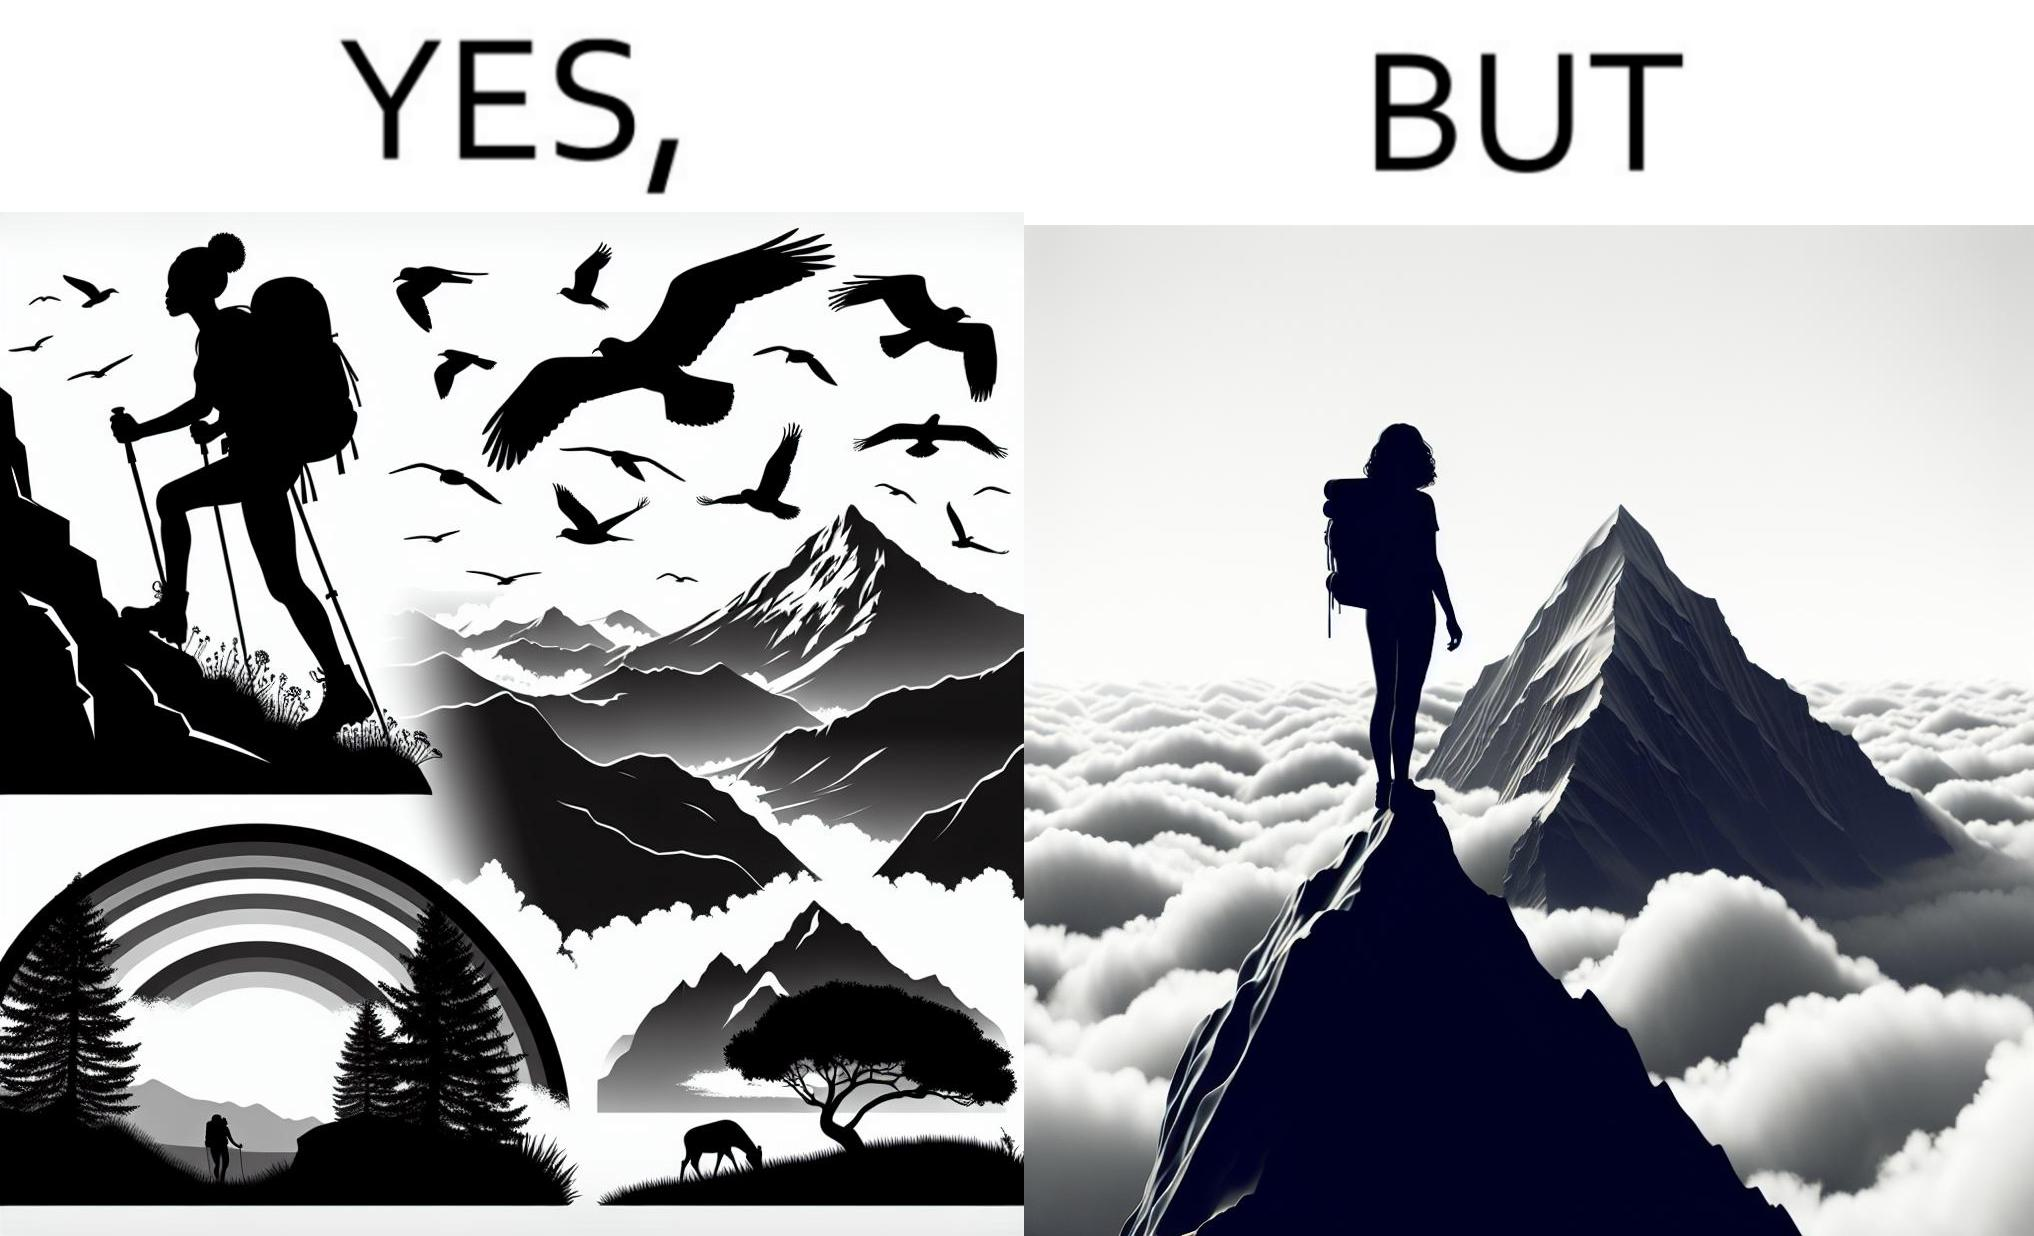What makes this image funny or satirical? The image is ironic, because the mountaineer climbs up the mountain to view the world from the peak but due to so much cloud, at the top, nothing is visible whereas he was able to witness some awesome views while climbing up the mountain 